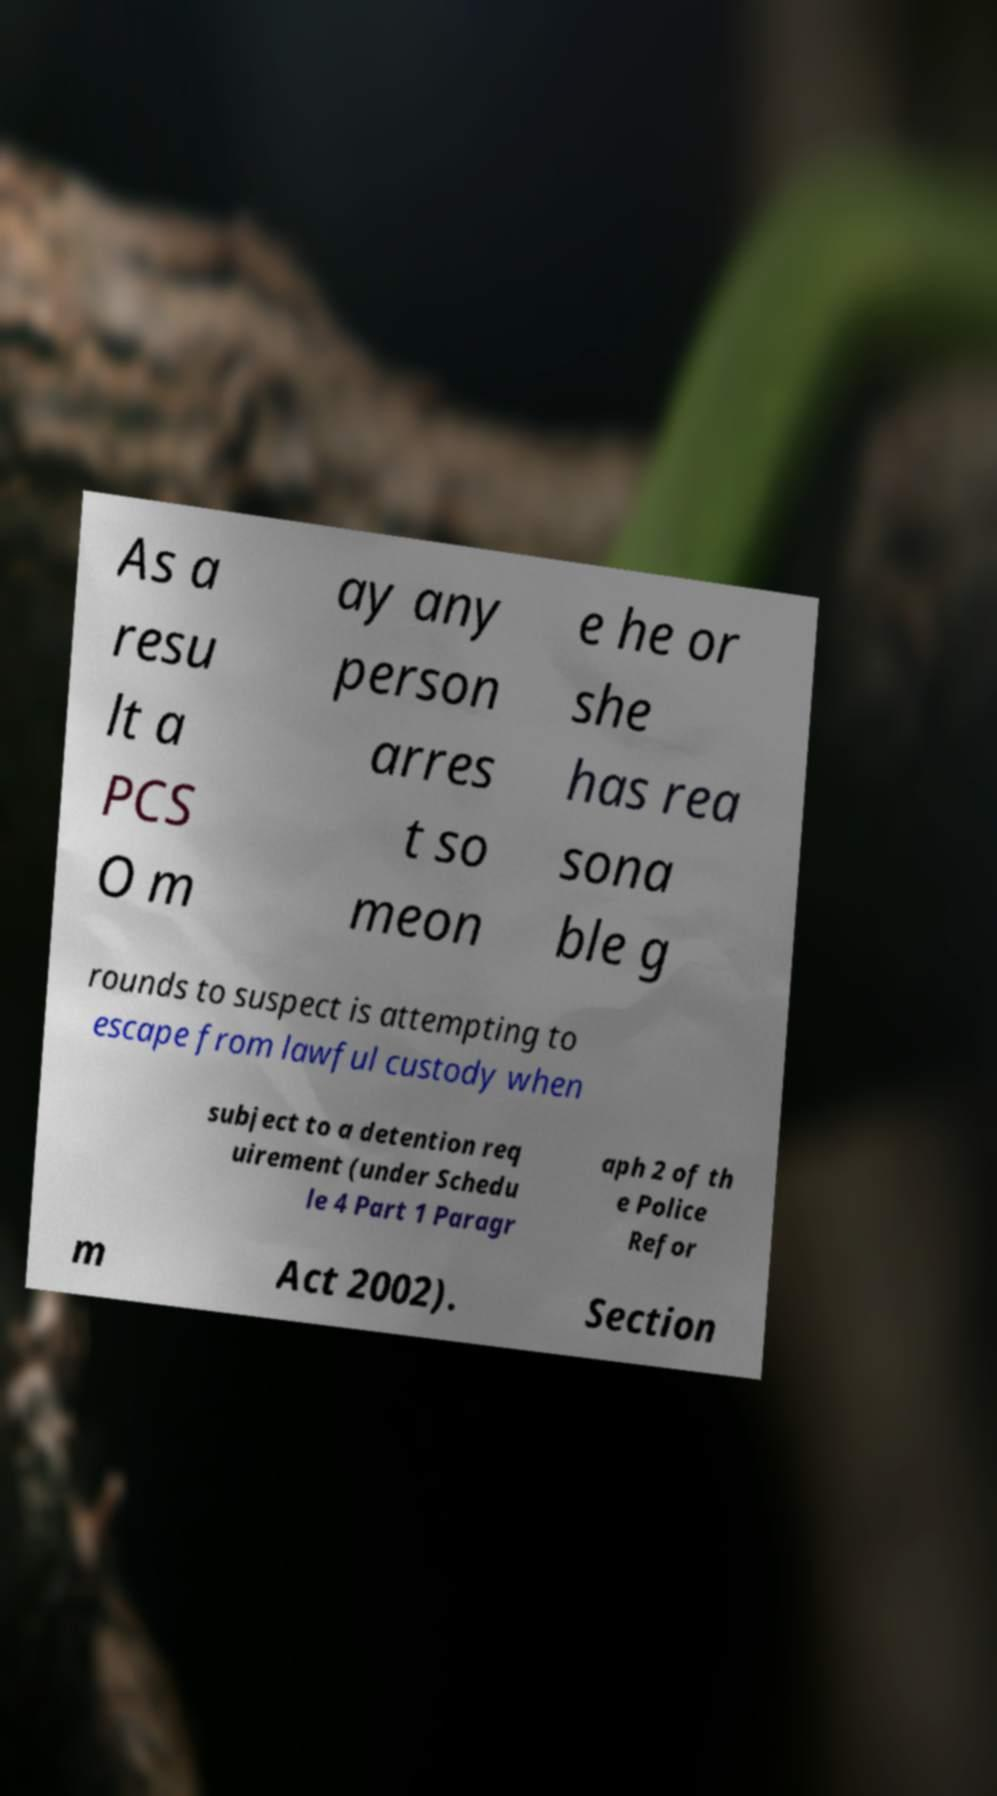There's text embedded in this image that I need extracted. Can you transcribe it verbatim? As a resu lt a PCS O m ay any person arres t so meon e he or she has rea sona ble g rounds to suspect is attempting to escape from lawful custody when subject to a detention req uirement (under Schedu le 4 Part 1 Paragr aph 2 of th e Police Refor m Act 2002). Section 